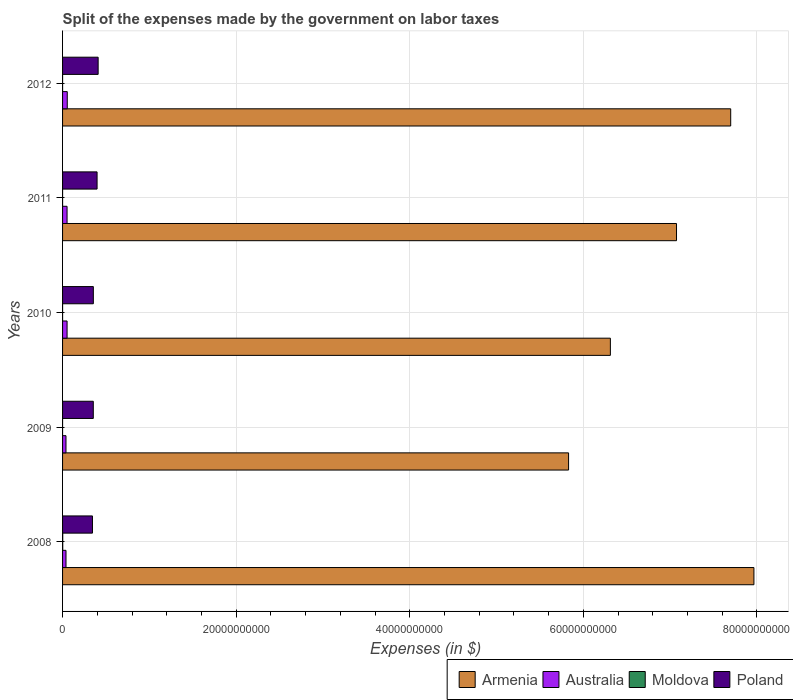How many different coloured bars are there?
Give a very brief answer. 4. How many bars are there on the 5th tick from the bottom?
Give a very brief answer. 4. What is the expenses made by the government on labor taxes in Poland in 2009?
Offer a very short reply. 3.54e+09. Across all years, what is the maximum expenses made by the government on labor taxes in Australia?
Offer a terse response. 5.41e+08. Across all years, what is the minimum expenses made by the government on labor taxes in Moldova?
Offer a terse response. 5.00e+05. In which year was the expenses made by the government on labor taxes in Moldova maximum?
Your answer should be very brief. 2008. In which year was the expenses made by the government on labor taxes in Australia minimum?
Give a very brief answer. 2009. What is the total expenses made by the government on labor taxes in Moldova in the graph?
Provide a succinct answer. 2.24e+07. What is the difference between the expenses made by the government on labor taxes in Australia in 2010 and that in 2012?
Your response must be concise. -2.20e+07. What is the difference between the expenses made by the government on labor taxes in Moldova in 2011 and the expenses made by the government on labor taxes in Armenia in 2012?
Your response must be concise. -7.70e+1. What is the average expenses made by the government on labor taxes in Armenia per year?
Ensure brevity in your answer.  6.98e+1. In the year 2008, what is the difference between the expenses made by the government on labor taxes in Armenia and expenses made by the government on labor taxes in Australia?
Make the answer very short. 7.93e+1. In how many years, is the expenses made by the government on labor taxes in Armenia greater than 8000000000 $?
Offer a very short reply. 5. What is the ratio of the expenses made by the government on labor taxes in Australia in 2008 to that in 2011?
Offer a very short reply. 0.76. Is the expenses made by the government on labor taxes in Poland in 2010 less than that in 2011?
Provide a short and direct response. Yes. What is the difference between the highest and the second highest expenses made by the government on labor taxes in Poland?
Ensure brevity in your answer.  1.23e+08. What is the difference between the highest and the lowest expenses made by the government on labor taxes in Australia?
Provide a short and direct response. 1.48e+08. In how many years, is the expenses made by the government on labor taxes in Armenia greater than the average expenses made by the government on labor taxes in Armenia taken over all years?
Make the answer very short. 3. Is the sum of the expenses made by the government on labor taxes in Armenia in 2009 and 2012 greater than the maximum expenses made by the government on labor taxes in Moldova across all years?
Give a very brief answer. Yes. Is it the case that in every year, the sum of the expenses made by the government on labor taxes in Australia and expenses made by the government on labor taxes in Moldova is greater than the sum of expenses made by the government on labor taxes in Armenia and expenses made by the government on labor taxes in Poland?
Offer a very short reply. No. What does the 2nd bar from the top in 2010 represents?
Offer a terse response. Moldova. What does the 3rd bar from the bottom in 2008 represents?
Keep it short and to the point. Moldova. Is it the case that in every year, the sum of the expenses made by the government on labor taxes in Armenia and expenses made by the government on labor taxes in Poland is greater than the expenses made by the government on labor taxes in Australia?
Your response must be concise. Yes. How many years are there in the graph?
Keep it short and to the point. 5. Are the values on the major ticks of X-axis written in scientific E-notation?
Your response must be concise. No. Does the graph contain grids?
Your answer should be very brief. Yes. Where does the legend appear in the graph?
Provide a succinct answer. Bottom right. How many legend labels are there?
Provide a succinct answer. 4. How are the legend labels stacked?
Offer a very short reply. Horizontal. What is the title of the graph?
Give a very brief answer. Split of the expenses made by the government on labor taxes. What is the label or title of the X-axis?
Your answer should be compact. Expenses (in $). What is the Expenses (in $) of Armenia in 2008?
Offer a terse response. 7.97e+1. What is the Expenses (in $) of Australia in 2008?
Make the answer very short. 3.96e+08. What is the Expenses (in $) of Moldova in 2008?
Give a very brief answer. 1.86e+07. What is the Expenses (in $) in Poland in 2008?
Give a very brief answer. 3.44e+09. What is the Expenses (in $) of Armenia in 2009?
Make the answer very short. 5.83e+1. What is the Expenses (in $) of Australia in 2009?
Offer a very short reply. 3.93e+08. What is the Expenses (in $) of Poland in 2009?
Your response must be concise. 3.54e+09. What is the Expenses (in $) in Armenia in 2010?
Keep it short and to the point. 6.31e+1. What is the Expenses (in $) in Australia in 2010?
Offer a terse response. 5.19e+08. What is the Expenses (in $) of Moldova in 2010?
Provide a succinct answer. 7.00e+05. What is the Expenses (in $) in Poland in 2010?
Keep it short and to the point. 3.55e+09. What is the Expenses (in $) of Armenia in 2011?
Keep it short and to the point. 7.07e+1. What is the Expenses (in $) of Australia in 2011?
Your response must be concise. 5.18e+08. What is the Expenses (in $) of Moldova in 2011?
Provide a short and direct response. 1.30e+06. What is the Expenses (in $) of Poland in 2011?
Ensure brevity in your answer.  3.98e+09. What is the Expenses (in $) in Armenia in 2012?
Offer a very short reply. 7.70e+1. What is the Expenses (in $) in Australia in 2012?
Give a very brief answer. 5.41e+08. What is the Expenses (in $) in Moldova in 2012?
Offer a terse response. 1.30e+06. What is the Expenses (in $) in Poland in 2012?
Provide a succinct answer. 4.10e+09. Across all years, what is the maximum Expenses (in $) of Armenia?
Your answer should be compact. 7.97e+1. Across all years, what is the maximum Expenses (in $) of Australia?
Offer a very short reply. 5.41e+08. Across all years, what is the maximum Expenses (in $) in Moldova?
Provide a short and direct response. 1.86e+07. Across all years, what is the maximum Expenses (in $) of Poland?
Your answer should be compact. 4.10e+09. Across all years, what is the minimum Expenses (in $) of Armenia?
Make the answer very short. 5.83e+1. Across all years, what is the minimum Expenses (in $) of Australia?
Give a very brief answer. 3.93e+08. Across all years, what is the minimum Expenses (in $) of Moldova?
Offer a terse response. 5.00e+05. Across all years, what is the minimum Expenses (in $) in Poland?
Your answer should be compact. 3.44e+09. What is the total Expenses (in $) of Armenia in the graph?
Offer a very short reply. 3.49e+11. What is the total Expenses (in $) of Australia in the graph?
Make the answer very short. 2.37e+09. What is the total Expenses (in $) in Moldova in the graph?
Keep it short and to the point. 2.24e+07. What is the total Expenses (in $) in Poland in the graph?
Give a very brief answer. 1.86e+1. What is the difference between the Expenses (in $) in Armenia in 2008 and that in 2009?
Give a very brief answer. 2.14e+1. What is the difference between the Expenses (in $) in Australia in 2008 and that in 2009?
Your answer should be compact. 3.00e+06. What is the difference between the Expenses (in $) in Moldova in 2008 and that in 2009?
Your answer should be very brief. 1.81e+07. What is the difference between the Expenses (in $) of Poland in 2008 and that in 2009?
Your answer should be very brief. -9.50e+07. What is the difference between the Expenses (in $) in Armenia in 2008 and that in 2010?
Keep it short and to the point. 1.65e+1. What is the difference between the Expenses (in $) of Australia in 2008 and that in 2010?
Ensure brevity in your answer.  -1.23e+08. What is the difference between the Expenses (in $) in Moldova in 2008 and that in 2010?
Offer a terse response. 1.79e+07. What is the difference between the Expenses (in $) in Poland in 2008 and that in 2010?
Offer a very short reply. -1.01e+08. What is the difference between the Expenses (in $) of Armenia in 2008 and that in 2011?
Ensure brevity in your answer.  8.92e+09. What is the difference between the Expenses (in $) in Australia in 2008 and that in 2011?
Provide a succinct answer. -1.22e+08. What is the difference between the Expenses (in $) of Moldova in 2008 and that in 2011?
Offer a very short reply. 1.73e+07. What is the difference between the Expenses (in $) in Poland in 2008 and that in 2011?
Provide a succinct answer. -5.31e+08. What is the difference between the Expenses (in $) of Armenia in 2008 and that in 2012?
Give a very brief answer. 2.67e+09. What is the difference between the Expenses (in $) of Australia in 2008 and that in 2012?
Offer a very short reply. -1.45e+08. What is the difference between the Expenses (in $) in Moldova in 2008 and that in 2012?
Keep it short and to the point. 1.73e+07. What is the difference between the Expenses (in $) of Poland in 2008 and that in 2012?
Offer a very short reply. -6.54e+08. What is the difference between the Expenses (in $) of Armenia in 2009 and that in 2010?
Make the answer very short. -4.82e+09. What is the difference between the Expenses (in $) in Australia in 2009 and that in 2010?
Your response must be concise. -1.26e+08. What is the difference between the Expenses (in $) in Moldova in 2009 and that in 2010?
Give a very brief answer. -2.00e+05. What is the difference between the Expenses (in $) in Poland in 2009 and that in 2010?
Make the answer very short. -6.00e+06. What is the difference between the Expenses (in $) of Armenia in 2009 and that in 2011?
Your answer should be very brief. -1.24e+1. What is the difference between the Expenses (in $) in Australia in 2009 and that in 2011?
Keep it short and to the point. -1.25e+08. What is the difference between the Expenses (in $) of Moldova in 2009 and that in 2011?
Offer a very short reply. -8.00e+05. What is the difference between the Expenses (in $) of Poland in 2009 and that in 2011?
Your response must be concise. -4.36e+08. What is the difference between the Expenses (in $) in Armenia in 2009 and that in 2012?
Your answer should be very brief. -1.87e+1. What is the difference between the Expenses (in $) in Australia in 2009 and that in 2012?
Offer a very short reply. -1.48e+08. What is the difference between the Expenses (in $) in Moldova in 2009 and that in 2012?
Give a very brief answer. -8.00e+05. What is the difference between the Expenses (in $) in Poland in 2009 and that in 2012?
Offer a very short reply. -5.59e+08. What is the difference between the Expenses (in $) of Armenia in 2010 and that in 2011?
Provide a short and direct response. -7.62e+09. What is the difference between the Expenses (in $) of Australia in 2010 and that in 2011?
Your response must be concise. 1.00e+06. What is the difference between the Expenses (in $) of Moldova in 2010 and that in 2011?
Your answer should be compact. -6.00e+05. What is the difference between the Expenses (in $) in Poland in 2010 and that in 2011?
Your answer should be very brief. -4.30e+08. What is the difference between the Expenses (in $) in Armenia in 2010 and that in 2012?
Ensure brevity in your answer.  -1.39e+1. What is the difference between the Expenses (in $) in Australia in 2010 and that in 2012?
Your answer should be compact. -2.20e+07. What is the difference between the Expenses (in $) in Moldova in 2010 and that in 2012?
Provide a succinct answer. -6.00e+05. What is the difference between the Expenses (in $) in Poland in 2010 and that in 2012?
Your response must be concise. -5.53e+08. What is the difference between the Expenses (in $) of Armenia in 2011 and that in 2012?
Keep it short and to the point. -6.24e+09. What is the difference between the Expenses (in $) of Australia in 2011 and that in 2012?
Offer a terse response. -2.30e+07. What is the difference between the Expenses (in $) in Poland in 2011 and that in 2012?
Your answer should be compact. -1.23e+08. What is the difference between the Expenses (in $) in Armenia in 2008 and the Expenses (in $) in Australia in 2009?
Ensure brevity in your answer.  7.93e+1. What is the difference between the Expenses (in $) in Armenia in 2008 and the Expenses (in $) in Moldova in 2009?
Your answer should be very brief. 7.97e+1. What is the difference between the Expenses (in $) in Armenia in 2008 and the Expenses (in $) in Poland in 2009?
Keep it short and to the point. 7.61e+1. What is the difference between the Expenses (in $) of Australia in 2008 and the Expenses (in $) of Moldova in 2009?
Ensure brevity in your answer.  3.96e+08. What is the difference between the Expenses (in $) of Australia in 2008 and the Expenses (in $) of Poland in 2009?
Provide a short and direct response. -3.14e+09. What is the difference between the Expenses (in $) in Moldova in 2008 and the Expenses (in $) in Poland in 2009?
Make the answer very short. -3.52e+09. What is the difference between the Expenses (in $) of Armenia in 2008 and the Expenses (in $) of Australia in 2010?
Your answer should be compact. 7.91e+1. What is the difference between the Expenses (in $) in Armenia in 2008 and the Expenses (in $) in Moldova in 2010?
Provide a short and direct response. 7.97e+1. What is the difference between the Expenses (in $) of Armenia in 2008 and the Expenses (in $) of Poland in 2010?
Offer a terse response. 7.61e+1. What is the difference between the Expenses (in $) in Australia in 2008 and the Expenses (in $) in Moldova in 2010?
Your response must be concise. 3.95e+08. What is the difference between the Expenses (in $) of Australia in 2008 and the Expenses (in $) of Poland in 2010?
Your answer should be very brief. -3.15e+09. What is the difference between the Expenses (in $) in Moldova in 2008 and the Expenses (in $) in Poland in 2010?
Offer a very short reply. -3.53e+09. What is the difference between the Expenses (in $) of Armenia in 2008 and the Expenses (in $) of Australia in 2011?
Offer a terse response. 7.91e+1. What is the difference between the Expenses (in $) in Armenia in 2008 and the Expenses (in $) in Moldova in 2011?
Keep it short and to the point. 7.97e+1. What is the difference between the Expenses (in $) of Armenia in 2008 and the Expenses (in $) of Poland in 2011?
Your answer should be very brief. 7.57e+1. What is the difference between the Expenses (in $) of Australia in 2008 and the Expenses (in $) of Moldova in 2011?
Your answer should be compact. 3.95e+08. What is the difference between the Expenses (in $) of Australia in 2008 and the Expenses (in $) of Poland in 2011?
Offer a terse response. -3.58e+09. What is the difference between the Expenses (in $) in Moldova in 2008 and the Expenses (in $) in Poland in 2011?
Give a very brief answer. -3.96e+09. What is the difference between the Expenses (in $) in Armenia in 2008 and the Expenses (in $) in Australia in 2012?
Ensure brevity in your answer.  7.91e+1. What is the difference between the Expenses (in $) in Armenia in 2008 and the Expenses (in $) in Moldova in 2012?
Offer a terse response. 7.97e+1. What is the difference between the Expenses (in $) of Armenia in 2008 and the Expenses (in $) of Poland in 2012?
Make the answer very short. 7.56e+1. What is the difference between the Expenses (in $) in Australia in 2008 and the Expenses (in $) in Moldova in 2012?
Keep it short and to the point. 3.95e+08. What is the difference between the Expenses (in $) in Australia in 2008 and the Expenses (in $) in Poland in 2012?
Offer a very short reply. -3.70e+09. What is the difference between the Expenses (in $) in Moldova in 2008 and the Expenses (in $) in Poland in 2012?
Ensure brevity in your answer.  -4.08e+09. What is the difference between the Expenses (in $) in Armenia in 2009 and the Expenses (in $) in Australia in 2010?
Make the answer very short. 5.78e+1. What is the difference between the Expenses (in $) of Armenia in 2009 and the Expenses (in $) of Moldova in 2010?
Provide a succinct answer. 5.83e+1. What is the difference between the Expenses (in $) in Armenia in 2009 and the Expenses (in $) in Poland in 2010?
Give a very brief answer. 5.48e+1. What is the difference between the Expenses (in $) of Australia in 2009 and the Expenses (in $) of Moldova in 2010?
Provide a short and direct response. 3.92e+08. What is the difference between the Expenses (in $) in Australia in 2009 and the Expenses (in $) in Poland in 2010?
Your response must be concise. -3.15e+09. What is the difference between the Expenses (in $) in Moldova in 2009 and the Expenses (in $) in Poland in 2010?
Provide a short and direct response. -3.55e+09. What is the difference between the Expenses (in $) of Armenia in 2009 and the Expenses (in $) of Australia in 2011?
Ensure brevity in your answer.  5.78e+1. What is the difference between the Expenses (in $) in Armenia in 2009 and the Expenses (in $) in Moldova in 2011?
Ensure brevity in your answer.  5.83e+1. What is the difference between the Expenses (in $) in Armenia in 2009 and the Expenses (in $) in Poland in 2011?
Ensure brevity in your answer.  5.43e+1. What is the difference between the Expenses (in $) in Australia in 2009 and the Expenses (in $) in Moldova in 2011?
Provide a short and direct response. 3.92e+08. What is the difference between the Expenses (in $) of Australia in 2009 and the Expenses (in $) of Poland in 2011?
Give a very brief answer. -3.58e+09. What is the difference between the Expenses (in $) in Moldova in 2009 and the Expenses (in $) in Poland in 2011?
Give a very brief answer. -3.98e+09. What is the difference between the Expenses (in $) in Armenia in 2009 and the Expenses (in $) in Australia in 2012?
Offer a terse response. 5.78e+1. What is the difference between the Expenses (in $) of Armenia in 2009 and the Expenses (in $) of Moldova in 2012?
Offer a very short reply. 5.83e+1. What is the difference between the Expenses (in $) of Armenia in 2009 and the Expenses (in $) of Poland in 2012?
Give a very brief answer. 5.42e+1. What is the difference between the Expenses (in $) of Australia in 2009 and the Expenses (in $) of Moldova in 2012?
Ensure brevity in your answer.  3.92e+08. What is the difference between the Expenses (in $) in Australia in 2009 and the Expenses (in $) in Poland in 2012?
Give a very brief answer. -3.71e+09. What is the difference between the Expenses (in $) in Moldova in 2009 and the Expenses (in $) in Poland in 2012?
Keep it short and to the point. -4.10e+09. What is the difference between the Expenses (in $) of Armenia in 2010 and the Expenses (in $) of Australia in 2011?
Ensure brevity in your answer.  6.26e+1. What is the difference between the Expenses (in $) in Armenia in 2010 and the Expenses (in $) in Moldova in 2011?
Provide a succinct answer. 6.31e+1. What is the difference between the Expenses (in $) of Armenia in 2010 and the Expenses (in $) of Poland in 2011?
Make the answer very short. 5.91e+1. What is the difference between the Expenses (in $) in Australia in 2010 and the Expenses (in $) in Moldova in 2011?
Offer a terse response. 5.18e+08. What is the difference between the Expenses (in $) in Australia in 2010 and the Expenses (in $) in Poland in 2011?
Offer a terse response. -3.46e+09. What is the difference between the Expenses (in $) in Moldova in 2010 and the Expenses (in $) in Poland in 2011?
Provide a succinct answer. -3.98e+09. What is the difference between the Expenses (in $) of Armenia in 2010 and the Expenses (in $) of Australia in 2012?
Offer a terse response. 6.26e+1. What is the difference between the Expenses (in $) in Armenia in 2010 and the Expenses (in $) in Moldova in 2012?
Your response must be concise. 6.31e+1. What is the difference between the Expenses (in $) of Armenia in 2010 and the Expenses (in $) of Poland in 2012?
Your answer should be compact. 5.90e+1. What is the difference between the Expenses (in $) of Australia in 2010 and the Expenses (in $) of Moldova in 2012?
Provide a succinct answer. 5.18e+08. What is the difference between the Expenses (in $) of Australia in 2010 and the Expenses (in $) of Poland in 2012?
Make the answer very short. -3.58e+09. What is the difference between the Expenses (in $) in Moldova in 2010 and the Expenses (in $) in Poland in 2012?
Your answer should be compact. -4.10e+09. What is the difference between the Expenses (in $) in Armenia in 2011 and the Expenses (in $) in Australia in 2012?
Your answer should be very brief. 7.02e+1. What is the difference between the Expenses (in $) in Armenia in 2011 and the Expenses (in $) in Moldova in 2012?
Provide a succinct answer. 7.07e+1. What is the difference between the Expenses (in $) in Armenia in 2011 and the Expenses (in $) in Poland in 2012?
Ensure brevity in your answer.  6.66e+1. What is the difference between the Expenses (in $) in Australia in 2011 and the Expenses (in $) in Moldova in 2012?
Your response must be concise. 5.17e+08. What is the difference between the Expenses (in $) in Australia in 2011 and the Expenses (in $) in Poland in 2012?
Make the answer very short. -3.58e+09. What is the difference between the Expenses (in $) in Moldova in 2011 and the Expenses (in $) in Poland in 2012?
Your response must be concise. -4.10e+09. What is the average Expenses (in $) in Armenia per year?
Give a very brief answer. 6.98e+1. What is the average Expenses (in $) of Australia per year?
Make the answer very short. 4.73e+08. What is the average Expenses (in $) in Moldova per year?
Offer a very short reply. 4.48e+06. What is the average Expenses (in $) of Poland per year?
Provide a short and direct response. 3.72e+09. In the year 2008, what is the difference between the Expenses (in $) of Armenia and Expenses (in $) of Australia?
Offer a very short reply. 7.93e+1. In the year 2008, what is the difference between the Expenses (in $) of Armenia and Expenses (in $) of Moldova?
Offer a very short reply. 7.96e+1. In the year 2008, what is the difference between the Expenses (in $) of Armenia and Expenses (in $) of Poland?
Offer a terse response. 7.62e+1. In the year 2008, what is the difference between the Expenses (in $) of Australia and Expenses (in $) of Moldova?
Your answer should be very brief. 3.77e+08. In the year 2008, what is the difference between the Expenses (in $) of Australia and Expenses (in $) of Poland?
Keep it short and to the point. -3.05e+09. In the year 2008, what is the difference between the Expenses (in $) in Moldova and Expenses (in $) in Poland?
Provide a short and direct response. -3.43e+09. In the year 2009, what is the difference between the Expenses (in $) of Armenia and Expenses (in $) of Australia?
Keep it short and to the point. 5.79e+1. In the year 2009, what is the difference between the Expenses (in $) in Armenia and Expenses (in $) in Moldova?
Offer a very short reply. 5.83e+1. In the year 2009, what is the difference between the Expenses (in $) of Armenia and Expenses (in $) of Poland?
Make the answer very short. 5.48e+1. In the year 2009, what is the difference between the Expenses (in $) of Australia and Expenses (in $) of Moldova?
Offer a terse response. 3.92e+08. In the year 2009, what is the difference between the Expenses (in $) of Australia and Expenses (in $) of Poland?
Your response must be concise. -3.15e+09. In the year 2009, what is the difference between the Expenses (in $) of Moldova and Expenses (in $) of Poland?
Make the answer very short. -3.54e+09. In the year 2010, what is the difference between the Expenses (in $) in Armenia and Expenses (in $) in Australia?
Provide a short and direct response. 6.26e+1. In the year 2010, what is the difference between the Expenses (in $) of Armenia and Expenses (in $) of Moldova?
Make the answer very short. 6.31e+1. In the year 2010, what is the difference between the Expenses (in $) in Armenia and Expenses (in $) in Poland?
Ensure brevity in your answer.  5.96e+1. In the year 2010, what is the difference between the Expenses (in $) of Australia and Expenses (in $) of Moldova?
Ensure brevity in your answer.  5.18e+08. In the year 2010, what is the difference between the Expenses (in $) of Australia and Expenses (in $) of Poland?
Your response must be concise. -3.03e+09. In the year 2010, what is the difference between the Expenses (in $) of Moldova and Expenses (in $) of Poland?
Provide a succinct answer. -3.55e+09. In the year 2011, what is the difference between the Expenses (in $) of Armenia and Expenses (in $) of Australia?
Give a very brief answer. 7.02e+1. In the year 2011, what is the difference between the Expenses (in $) of Armenia and Expenses (in $) of Moldova?
Your response must be concise. 7.07e+1. In the year 2011, what is the difference between the Expenses (in $) in Armenia and Expenses (in $) in Poland?
Your answer should be very brief. 6.68e+1. In the year 2011, what is the difference between the Expenses (in $) of Australia and Expenses (in $) of Moldova?
Provide a short and direct response. 5.17e+08. In the year 2011, what is the difference between the Expenses (in $) in Australia and Expenses (in $) in Poland?
Give a very brief answer. -3.46e+09. In the year 2011, what is the difference between the Expenses (in $) of Moldova and Expenses (in $) of Poland?
Your answer should be very brief. -3.97e+09. In the year 2012, what is the difference between the Expenses (in $) in Armenia and Expenses (in $) in Australia?
Keep it short and to the point. 7.64e+1. In the year 2012, what is the difference between the Expenses (in $) in Armenia and Expenses (in $) in Moldova?
Ensure brevity in your answer.  7.70e+1. In the year 2012, what is the difference between the Expenses (in $) in Armenia and Expenses (in $) in Poland?
Your answer should be compact. 7.29e+1. In the year 2012, what is the difference between the Expenses (in $) of Australia and Expenses (in $) of Moldova?
Offer a very short reply. 5.40e+08. In the year 2012, what is the difference between the Expenses (in $) in Australia and Expenses (in $) in Poland?
Provide a short and direct response. -3.56e+09. In the year 2012, what is the difference between the Expenses (in $) in Moldova and Expenses (in $) in Poland?
Your answer should be very brief. -4.10e+09. What is the ratio of the Expenses (in $) of Armenia in 2008 to that in 2009?
Provide a succinct answer. 1.37. What is the ratio of the Expenses (in $) of Australia in 2008 to that in 2009?
Provide a succinct answer. 1.01. What is the ratio of the Expenses (in $) in Moldova in 2008 to that in 2009?
Keep it short and to the point. 37.2. What is the ratio of the Expenses (in $) of Poland in 2008 to that in 2009?
Your response must be concise. 0.97. What is the ratio of the Expenses (in $) in Armenia in 2008 to that in 2010?
Give a very brief answer. 1.26. What is the ratio of the Expenses (in $) of Australia in 2008 to that in 2010?
Give a very brief answer. 0.76. What is the ratio of the Expenses (in $) in Moldova in 2008 to that in 2010?
Your response must be concise. 26.57. What is the ratio of the Expenses (in $) of Poland in 2008 to that in 2010?
Your answer should be compact. 0.97. What is the ratio of the Expenses (in $) in Armenia in 2008 to that in 2011?
Offer a very short reply. 1.13. What is the ratio of the Expenses (in $) of Australia in 2008 to that in 2011?
Your response must be concise. 0.76. What is the ratio of the Expenses (in $) of Moldova in 2008 to that in 2011?
Give a very brief answer. 14.31. What is the ratio of the Expenses (in $) in Poland in 2008 to that in 2011?
Provide a succinct answer. 0.87. What is the ratio of the Expenses (in $) in Armenia in 2008 to that in 2012?
Provide a succinct answer. 1.03. What is the ratio of the Expenses (in $) in Australia in 2008 to that in 2012?
Provide a succinct answer. 0.73. What is the ratio of the Expenses (in $) of Moldova in 2008 to that in 2012?
Make the answer very short. 14.31. What is the ratio of the Expenses (in $) of Poland in 2008 to that in 2012?
Keep it short and to the point. 0.84. What is the ratio of the Expenses (in $) in Armenia in 2009 to that in 2010?
Keep it short and to the point. 0.92. What is the ratio of the Expenses (in $) in Australia in 2009 to that in 2010?
Offer a terse response. 0.76. What is the ratio of the Expenses (in $) of Moldova in 2009 to that in 2010?
Make the answer very short. 0.71. What is the ratio of the Expenses (in $) of Poland in 2009 to that in 2010?
Your answer should be compact. 1. What is the ratio of the Expenses (in $) in Armenia in 2009 to that in 2011?
Make the answer very short. 0.82. What is the ratio of the Expenses (in $) in Australia in 2009 to that in 2011?
Offer a very short reply. 0.76. What is the ratio of the Expenses (in $) of Moldova in 2009 to that in 2011?
Provide a short and direct response. 0.38. What is the ratio of the Expenses (in $) of Poland in 2009 to that in 2011?
Offer a very short reply. 0.89. What is the ratio of the Expenses (in $) in Armenia in 2009 to that in 2012?
Keep it short and to the point. 0.76. What is the ratio of the Expenses (in $) in Australia in 2009 to that in 2012?
Your answer should be compact. 0.73. What is the ratio of the Expenses (in $) in Moldova in 2009 to that in 2012?
Provide a succinct answer. 0.38. What is the ratio of the Expenses (in $) of Poland in 2009 to that in 2012?
Offer a very short reply. 0.86. What is the ratio of the Expenses (in $) of Armenia in 2010 to that in 2011?
Offer a very short reply. 0.89. What is the ratio of the Expenses (in $) in Moldova in 2010 to that in 2011?
Offer a terse response. 0.54. What is the ratio of the Expenses (in $) of Poland in 2010 to that in 2011?
Offer a terse response. 0.89. What is the ratio of the Expenses (in $) of Armenia in 2010 to that in 2012?
Offer a terse response. 0.82. What is the ratio of the Expenses (in $) in Australia in 2010 to that in 2012?
Your response must be concise. 0.96. What is the ratio of the Expenses (in $) of Moldova in 2010 to that in 2012?
Provide a short and direct response. 0.54. What is the ratio of the Expenses (in $) in Poland in 2010 to that in 2012?
Ensure brevity in your answer.  0.87. What is the ratio of the Expenses (in $) of Armenia in 2011 to that in 2012?
Give a very brief answer. 0.92. What is the ratio of the Expenses (in $) in Australia in 2011 to that in 2012?
Ensure brevity in your answer.  0.96. What is the ratio of the Expenses (in $) in Moldova in 2011 to that in 2012?
Your answer should be very brief. 1. What is the ratio of the Expenses (in $) of Poland in 2011 to that in 2012?
Your response must be concise. 0.97. What is the difference between the highest and the second highest Expenses (in $) of Armenia?
Ensure brevity in your answer.  2.67e+09. What is the difference between the highest and the second highest Expenses (in $) of Australia?
Your answer should be very brief. 2.20e+07. What is the difference between the highest and the second highest Expenses (in $) of Moldova?
Keep it short and to the point. 1.73e+07. What is the difference between the highest and the second highest Expenses (in $) of Poland?
Give a very brief answer. 1.23e+08. What is the difference between the highest and the lowest Expenses (in $) of Armenia?
Give a very brief answer. 2.14e+1. What is the difference between the highest and the lowest Expenses (in $) in Australia?
Your answer should be compact. 1.48e+08. What is the difference between the highest and the lowest Expenses (in $) in Moldova?
Offer a terse response. 1.81e+07. What is the difference between the highest and the lowest Expenses (in $) in Poland?
Make the answer very short. 6.54e+08. 